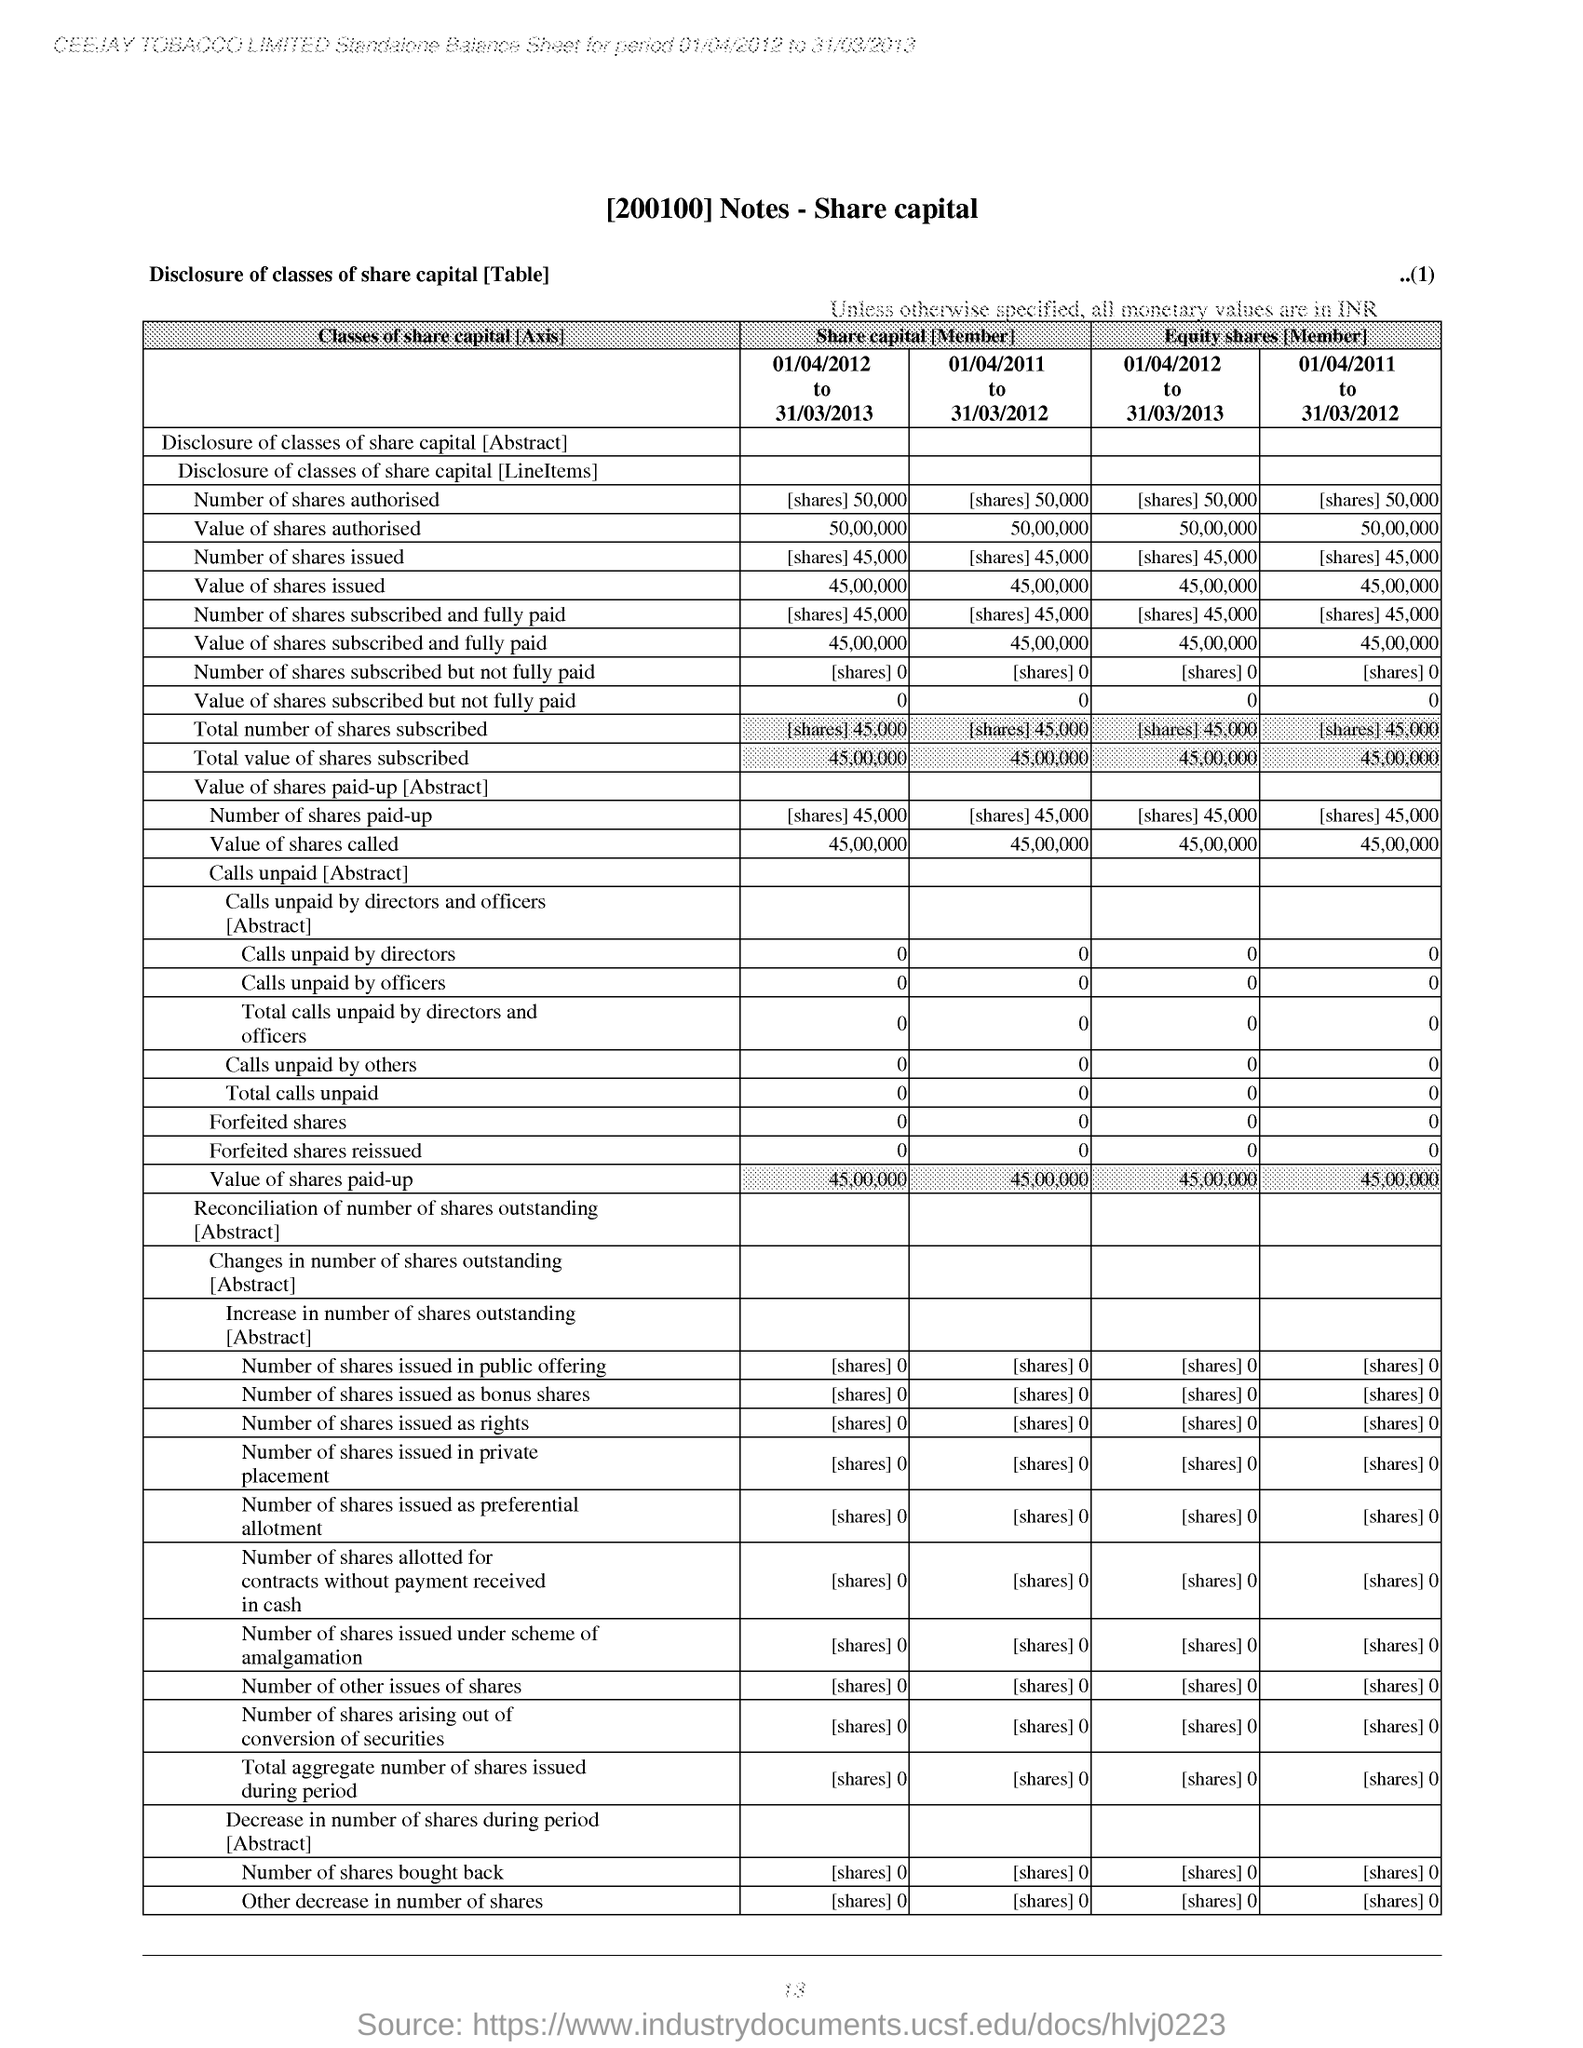What is the Page Number?
Your response must be concise. 13. 